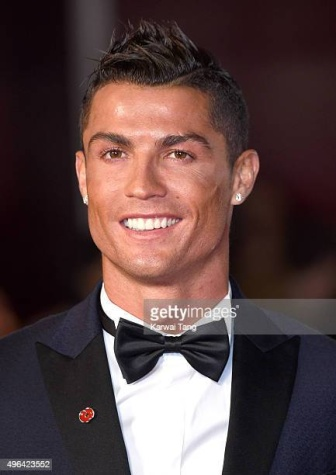Can you elaborate on the elements of the picture provided?
 The image captures a moment from a red carpet event featuring the professional soccer player, Cristiano Ronaldo. Ronaldo is the central figure in the image, dressed in a formal black tuxedo complemented by a crisp white shirt and a neatly tied black bow tie. A touch of color is added to his attire with a red flower pinned to his lapel. 

Ronaldo's demeanor is cheerful as he is seen smiling, his gaze directed towards the left of the frame. The background of the image is blurred, indicating a depth of field effect, but it suggests the presence of a crowd, possibly spectators or fans gathered for the event. The image does not contain any discernible text. The relative position of Ronaldo to the crowd implies he is the focus of the event, further emphasized by his sharp attire contrasting against the indistinct backdrop. 

This image encapsulates a snapshot of Ronaldo's public life, portraying him in a moment of celebration or recognition, surrounded yet set apart from the crowd. 